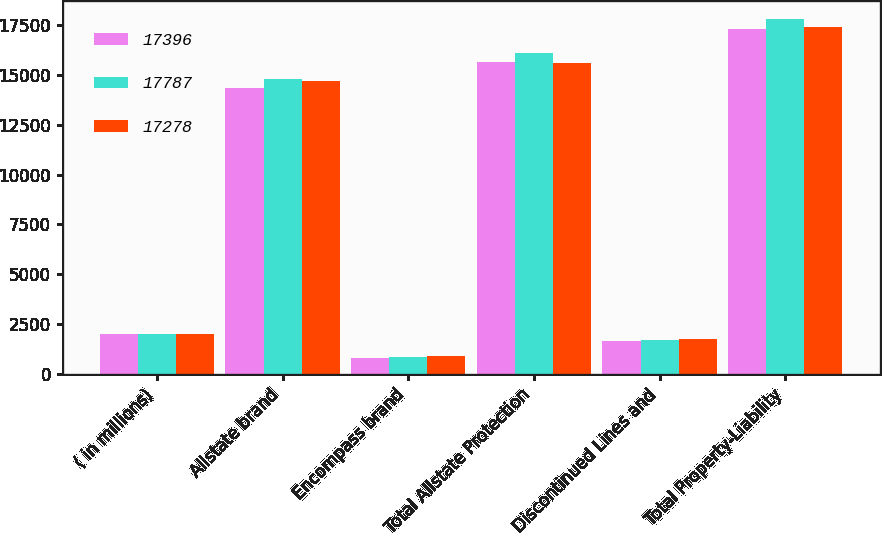Convert chart to OTSL. <chart><loc_0><loc_0><loc_500><loc_500><stacked_bar_chart><ecel><fcel>( in millions)<fcel>Allstate brand<fcel>Encompass brand<fcel>Total Allstate Protection<fcel>Discontinued Lines and<fcel>Total Property-Liability<nl><fcel>17396<fcel>2012<fcel>14364<fcel>807<fcel>15641<fcel>1637<fcel>17278<nl><fcel>17787<fcel>2011<fcel>14792<fcel>859<fcel>16080<fcel>1707<fcel>17787<nl><fcel>17278<fcel>2010<fcel>14696<fcel>921<fcel>15617<fcel>1779<fcel>17396<nl></chart> 